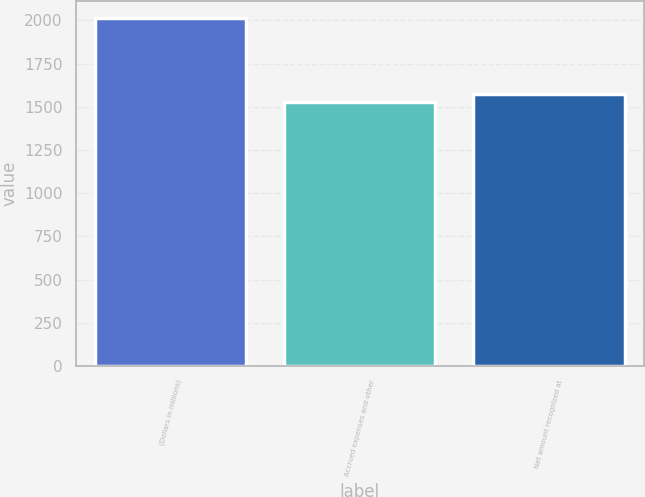<chart> <loc_0><loc_0><loc_500><loc_500><bar_chart><fcel>(Dollars in millions)<fcel>Accrued expenses and other<fcel>Net amount recognized at<nl><fcel>2011<fcel>1528<fcel>1576.3<nl></chart> 